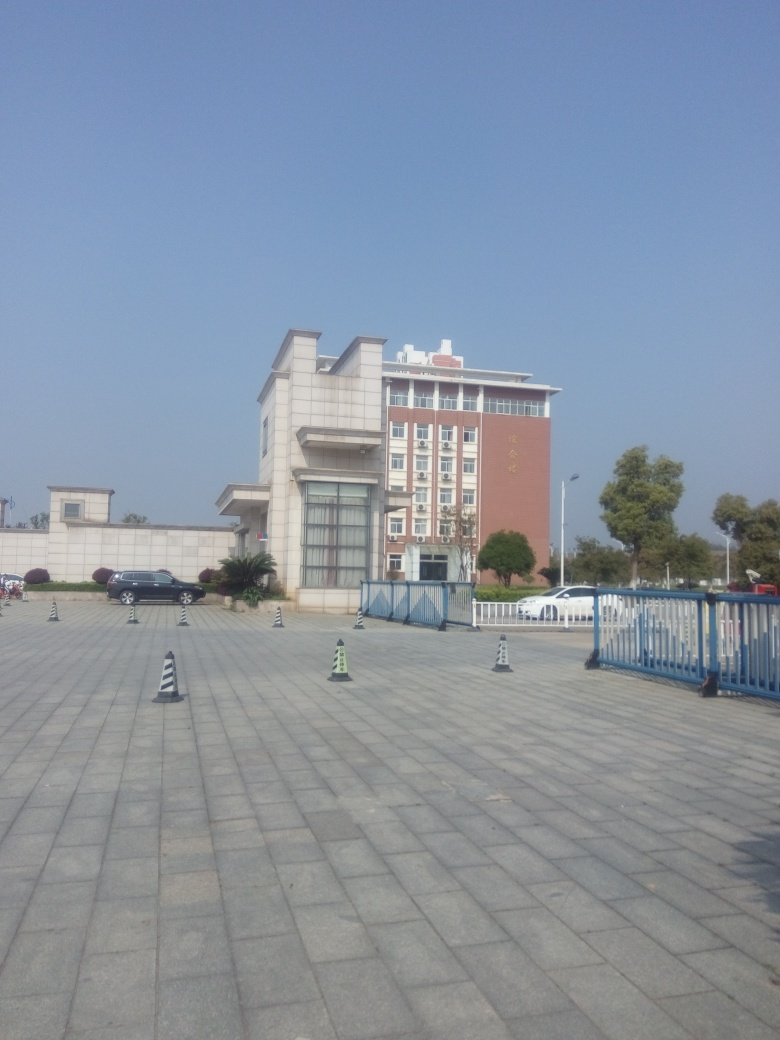Can you tell what time of day it is based on the shadows in the image? Given the length and angle of the shadows cast by the traffic cones and elements of the building, it appears to be late morning or early afternoon when the sun is relatively high in the sky, creating shorter shadows. 